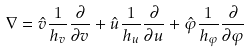<formula> <loc_0><loc_0><loc_500><loc_500>\nabla = \hat { v } \frac { 1 } { h _ { v } } \frac { \partial } { \partial v } + \hat { u } \frac { 1 } { h _ { u } } \frac { \partial } { \partial u } + \hat { \varphi } \frac { 1 } { h _ { \varphi } } \frac { \partial } { \partial \varphi }</formula> 